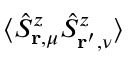Convert formula to latex. <formula><loc_0><loc_0><loc_500><loc_500>\langle \hat { S } _ { r , \mu } ^ { z } \hat { S } _ { r ^ { \prime } , \nu } ^ { z } \rangle</formula> 